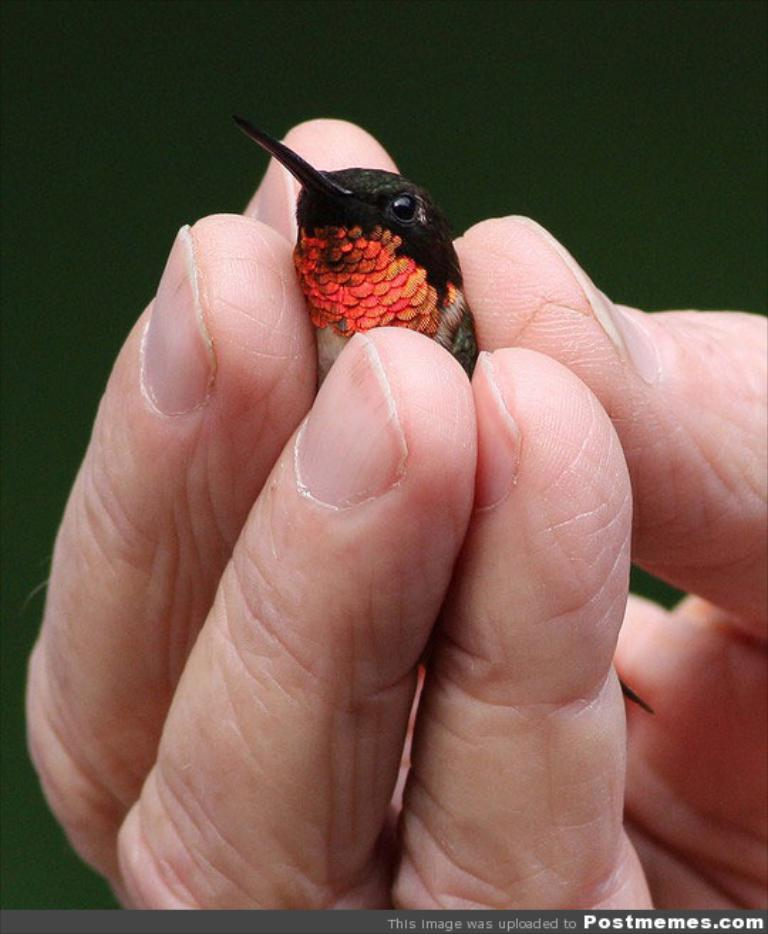What can be seen in the image? There is a person's hand in the image. What is the hand holding? The hand is holding a bird. What type of locket can be seen hanging from the bird's neck in the image? There is no locket present in the image, nor is there any indication that the bird has a necklace or any other accessory. 